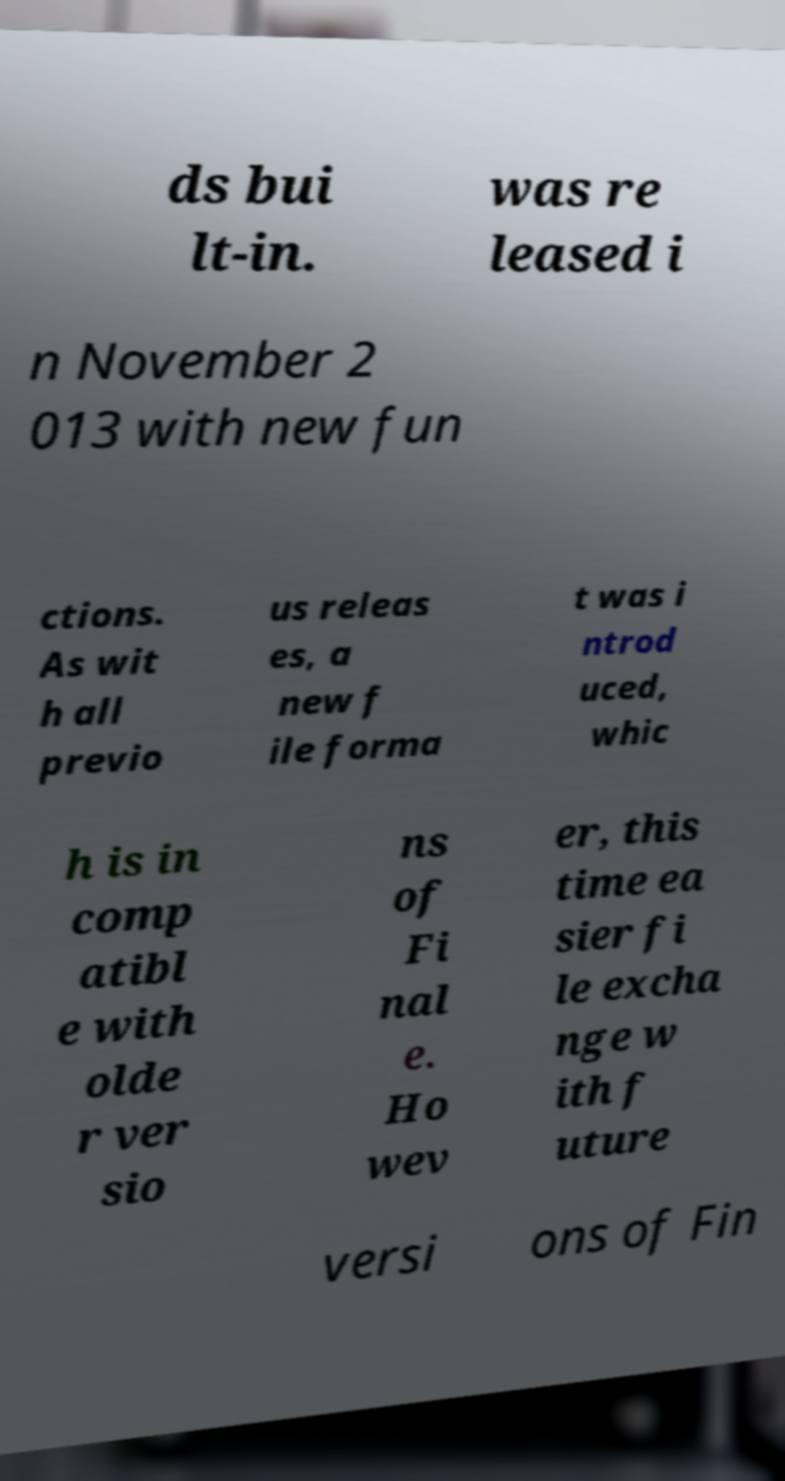What messages or text are displayed in this image? I need them in a readable, typed format. ds bui lt-in. was re leased i n November 2 013 with new fun ctions. As wit h all previo us releas es, a new f ile forma t was i ntrod uced, whic h is in comp atibl e with olde r ver sio ns of Fi nal e. Ho wev er, this time ea sier fi le excha nge w ith f uture versi ons of Fin 